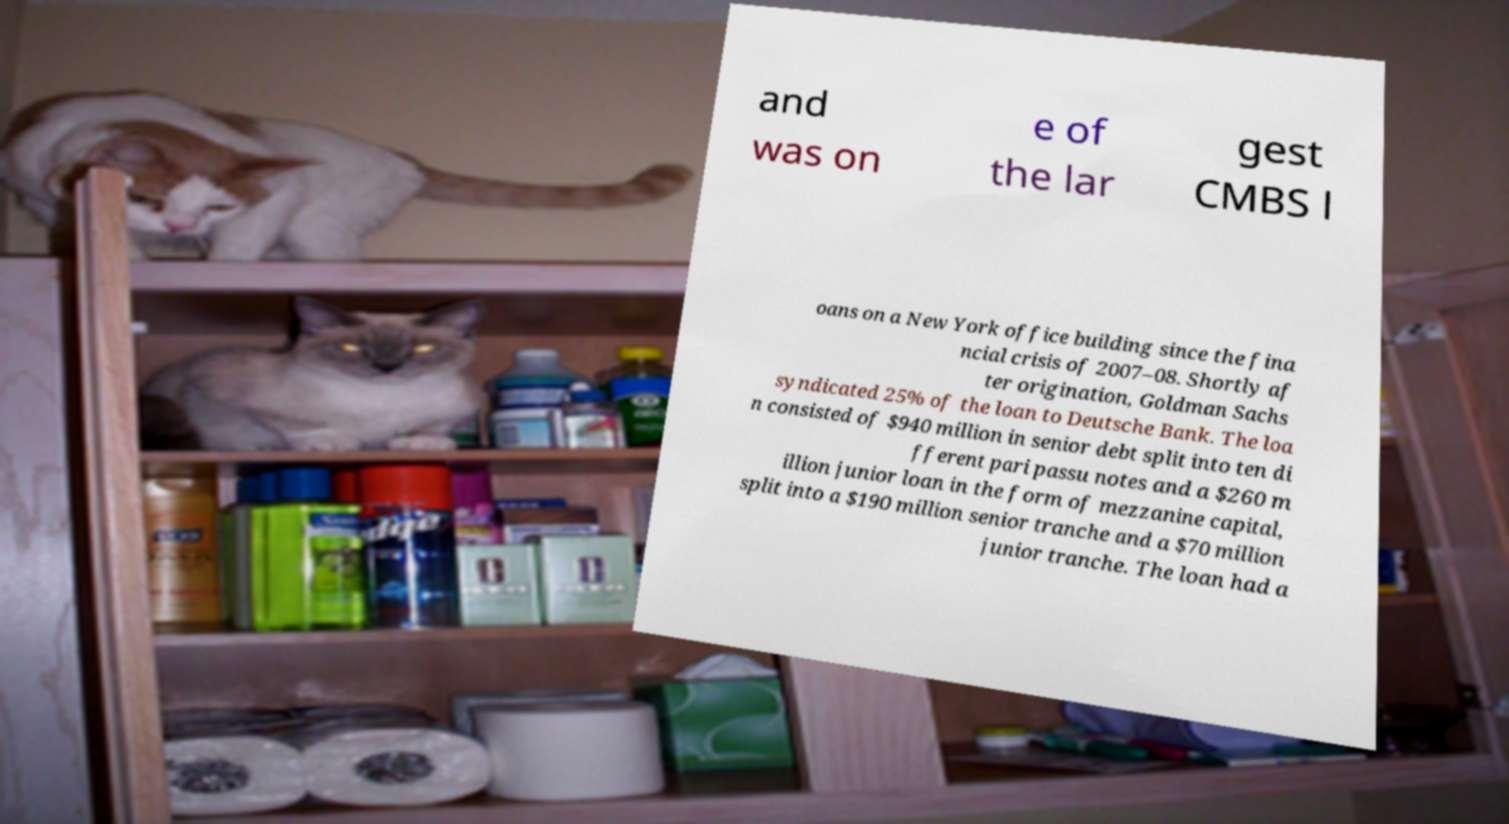Could you extract and type out the text from this image? and was on e of the lar gest CMBS l oans on a New York office building since the fina ncial crisis of 2007–08. Shortly af ter origination, Goldman Sachs syndicated 25% of the loan to Deutsche Bank. The loa n consisted of $940 million in senior debt split into ten di fferent pari passu notes and a $260 m illion junior loan in the form of mezzanine capital, split into a $190 million senior tranche and a $70 million junior tranche. The loan had a 